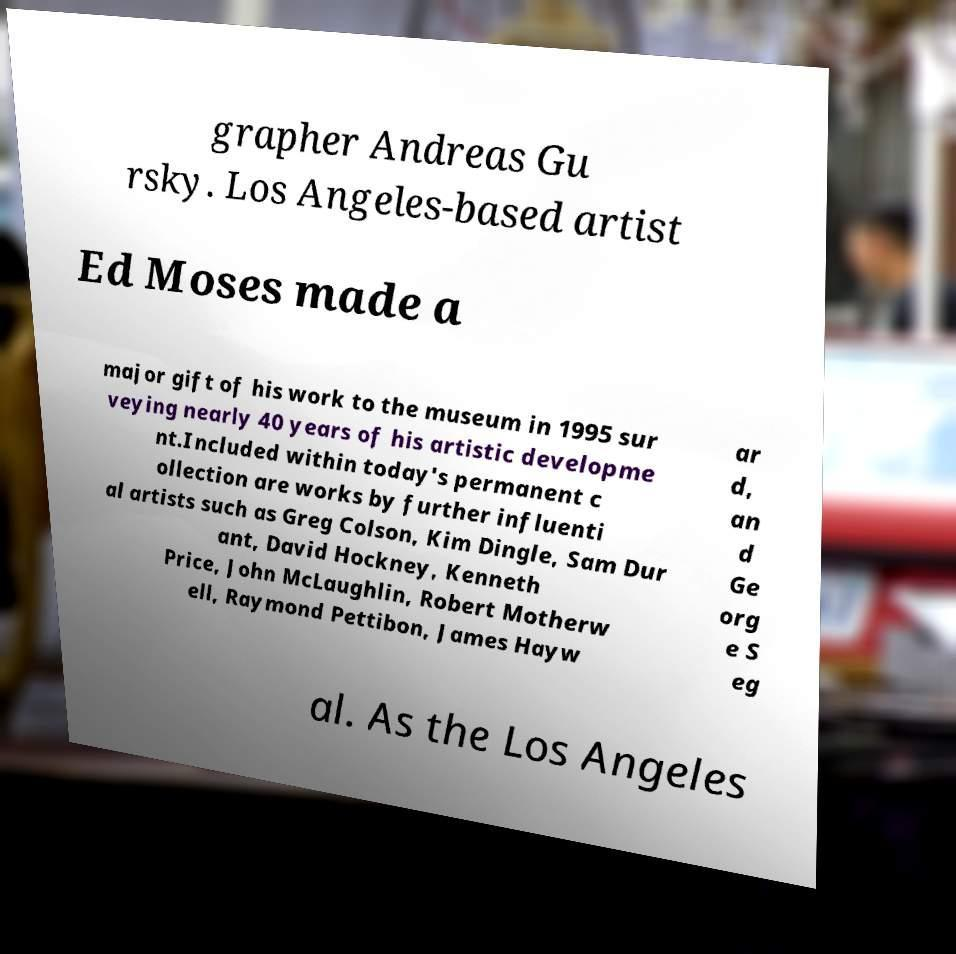Can you accurately transcribe the text from the provided image for me? grapher Andreas Gu rsky. Los Angeles-based artist Ed Moses made a major gift of his work to the museum in 1995 sur veying nearly 40 years of his artistic developme nt.Included within today's permanent c ollection are works by further influenti al artists such as Greg Colson, Kim Dingle, Sam Dur ant, David Hockney, Kenneth Price, John McLaughlin, Robert Motherw ell, Raymond Pettibon, James Hayw ar d, an d Ge org e S eg al. As the Los Angeles 